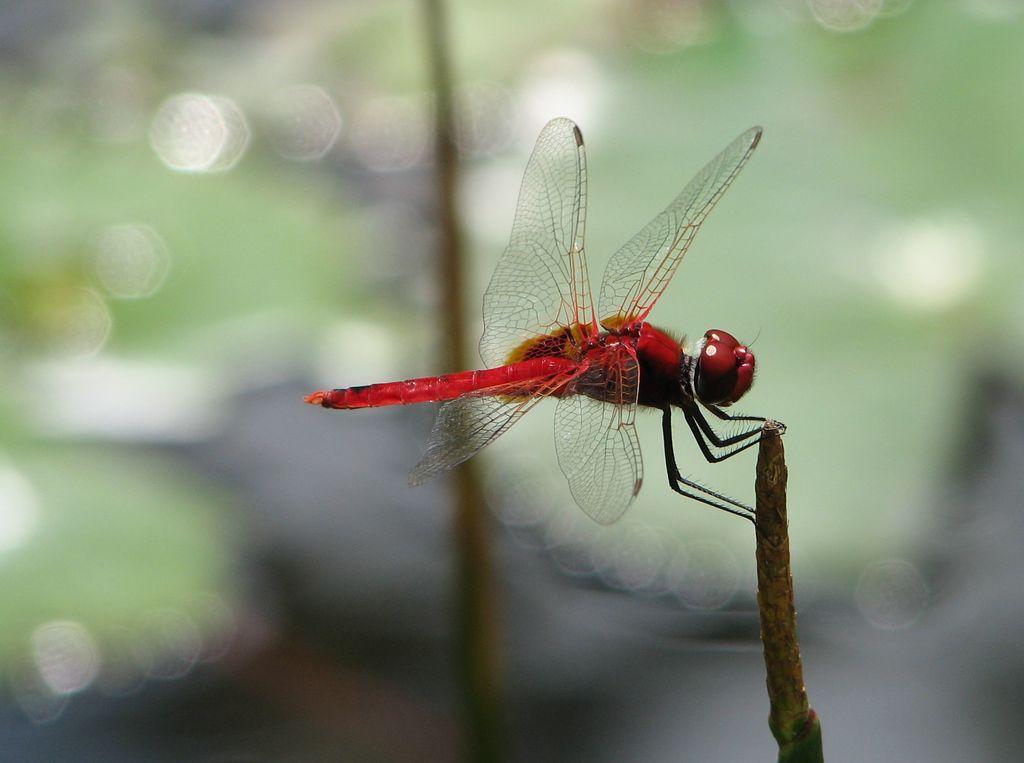In one or two sentences, can you explain what this image depicts? In this picture we can see a dragonfly on the stem and behind the dragonfly there is a blurred background. 